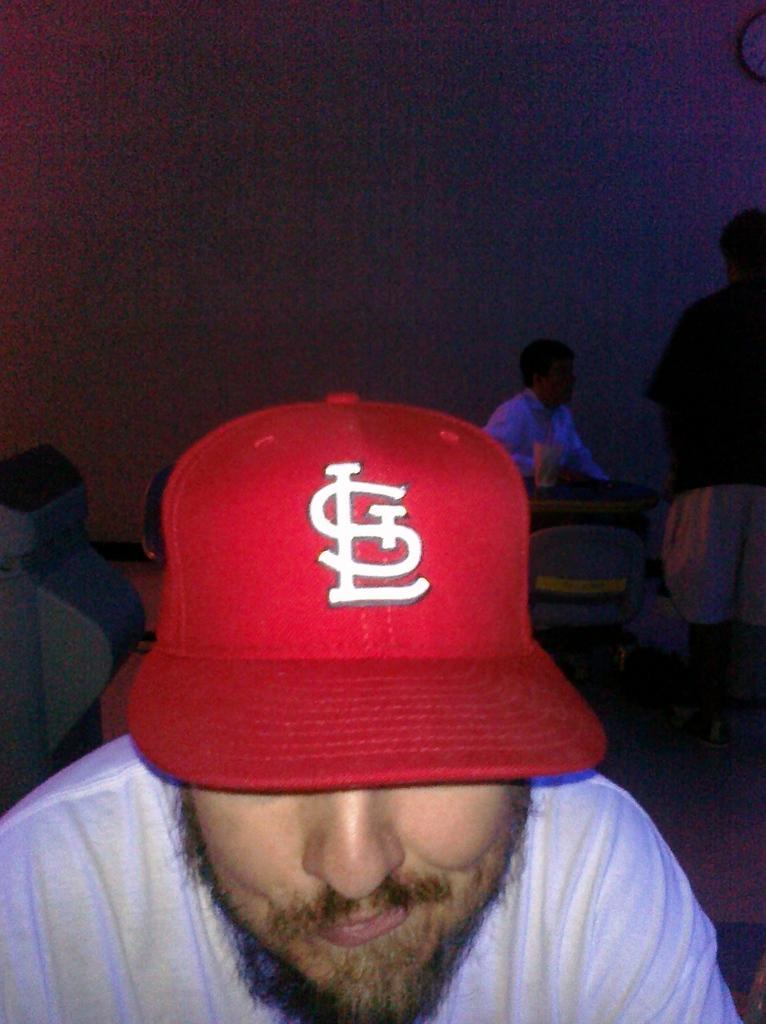How would you summarize this image in a sentence or two? In this image we can see three people in a room, a person is wearing a red color hat and in the background there is a chair and a table, on the table there is a glass and a clock attached to the wall. 